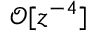<formula> <loc_0><loc_0><loc_500><loc_500>\mathcal { O } [ z ^ { - 4 } ]</formula> 